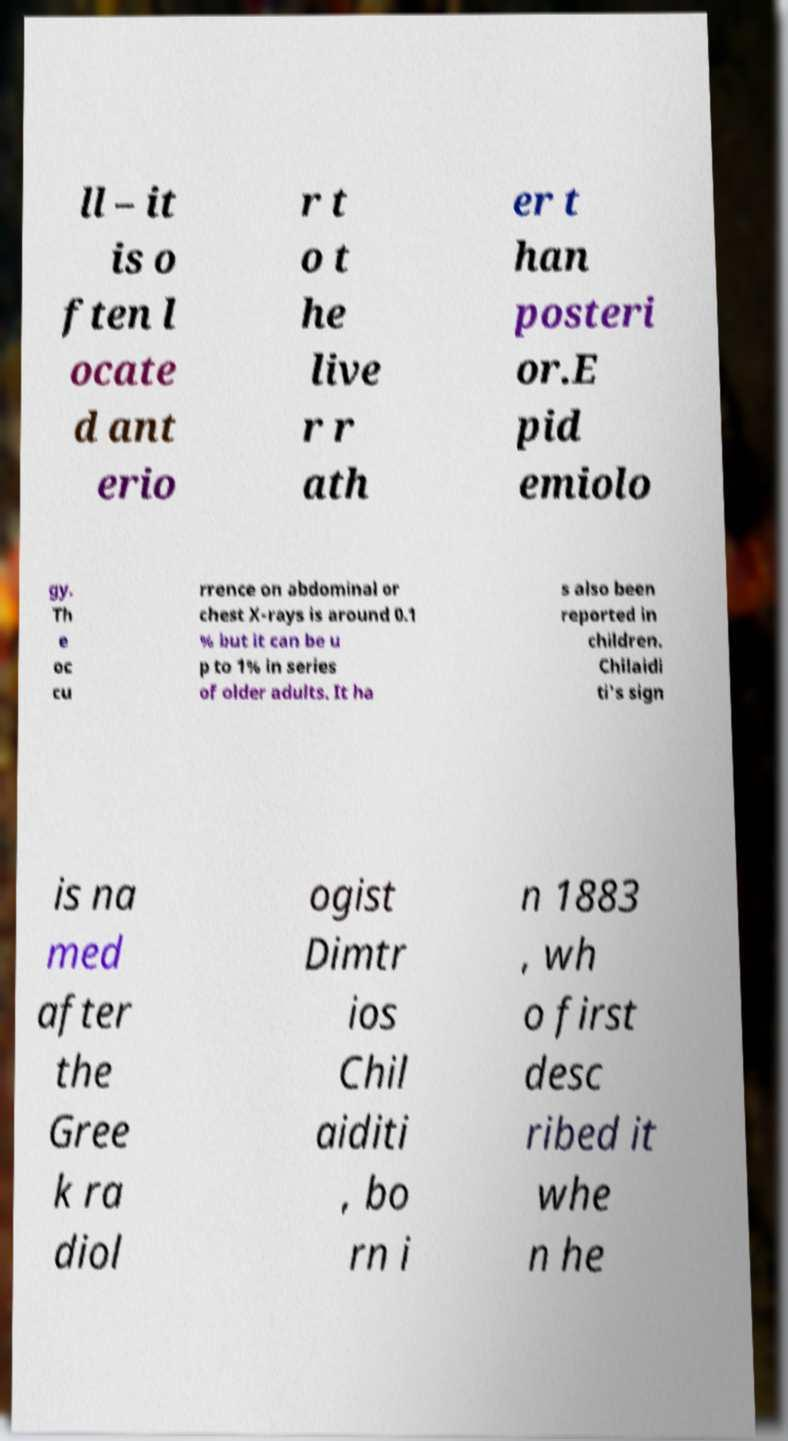Please identify and transcribe the text found in this image. ll – it is o ften l ocate d ant erio r t o t he live r r ath er t han posteri or.E pid emiolo gy. Th e oc cu rrence on abdominal or chest X-rays is around 0.1 % but it can be u p to 1% in series of older adults. It ha s also been reported in children. Chilaidi ti's sign is na med after the Gree k ra diol ogist Dimtr ios Chil aiditi , bo rn i n 1883 , wh o first desc ribed it whe n he 